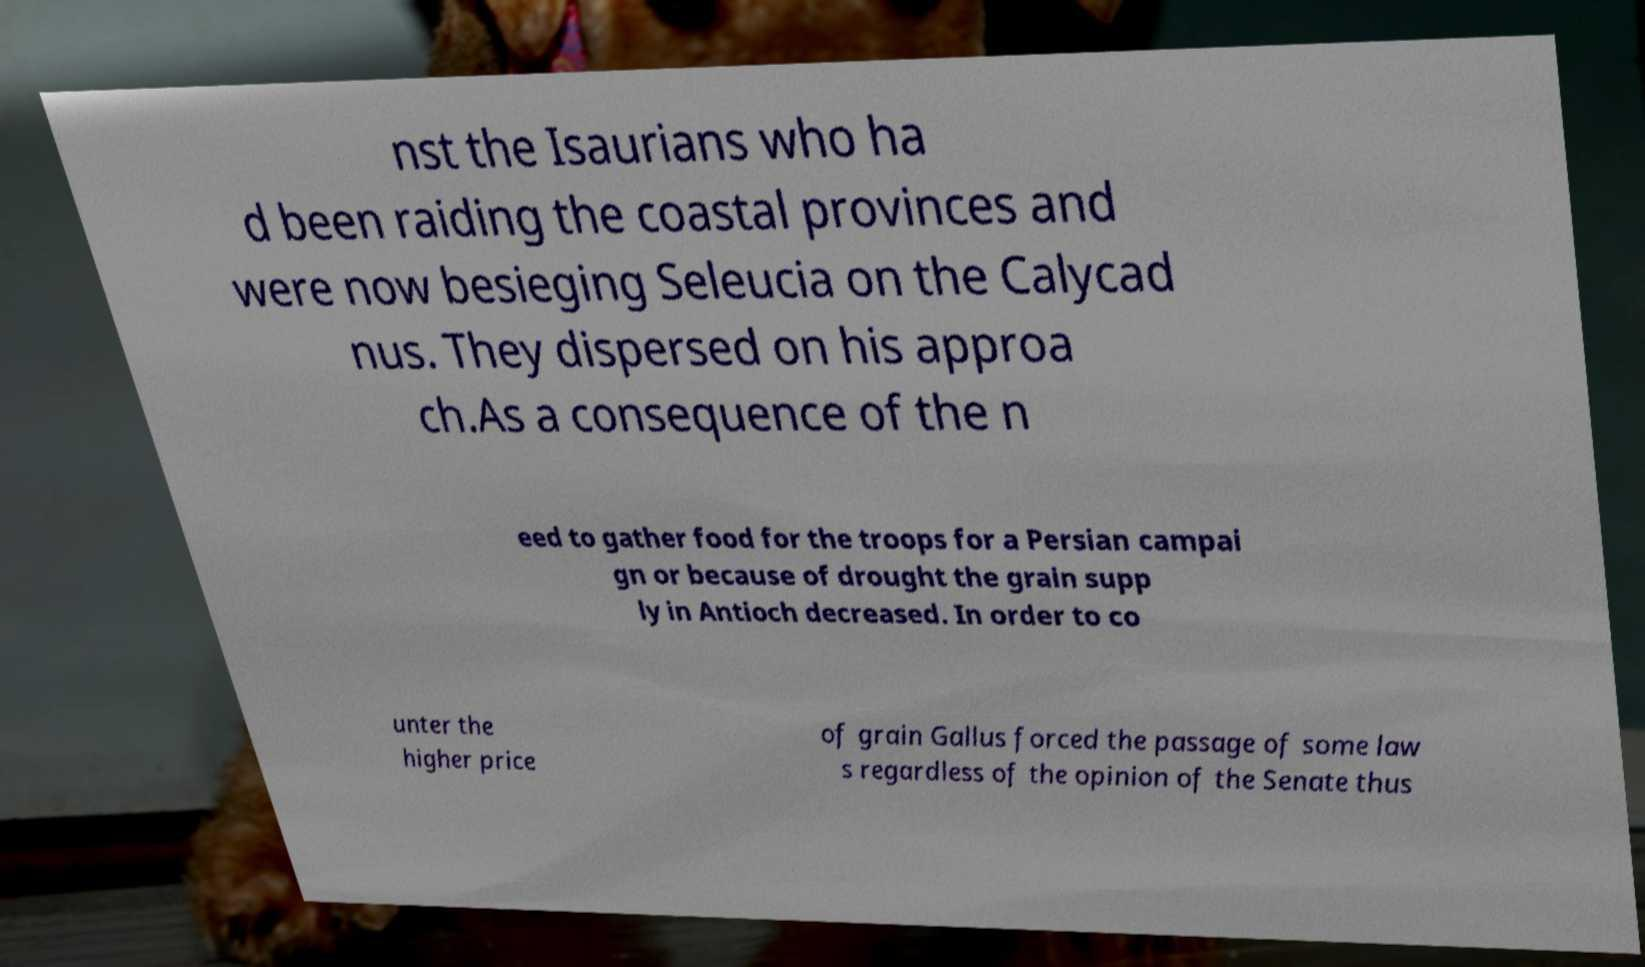I need the written content from this picture converted into text. Can you do that? nst the Isaurians who ha d been raiding the coastal provinces and were now besieging Seleucia on the Calycad nus. They dispersed on his approa ch.As a consequence of the n eed to gather food for the troops for a Persian campai gn or because of drought the grain supp ly in Antioch decreased. In order to co unter the higher price of grain Gallus forced the passage of some law s regardless of the opinion of the Senate thus 